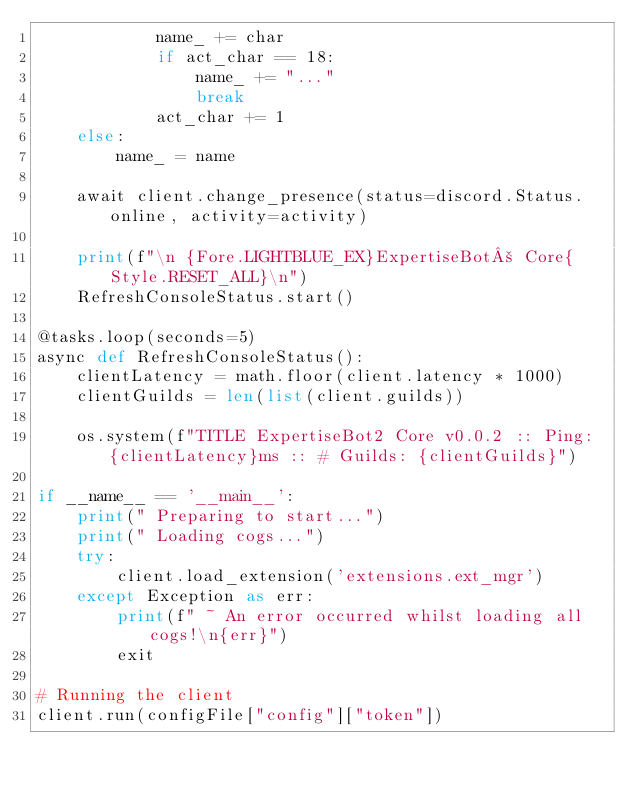Convert code to text. <code><loc_0><loc_0><loc_500><loc_500><_Python_>            name_ += char
            if act_char == 18:
                name_ += "..."
                break            
            act_char += 1
    else:
        name_ = name

    await client.change_presence(status=discord.Status.online, activity=activity)

    print(f"\n {Fore.LIGHTBLUE_EX}ExpertiseBot² Core{Style.RESET_ALL}\n")
    RefreshConsoleStatus.start()
    
@tasks.loop(seconds=5)
async def RefreshConsoleStatus():
    clientLatency = math.floor(client.latency * 1000)
    clientGuilds = len(list(client.guilds))
    
    os.system(f"TITLE ExpertiseBot2 Core v0.0.2 :: Ping: {clientLatency}ms :: # Guilds: {clientGuilds}")

if __name__ == '__main__':
    print(" Preparing to start...")
    print(" Loading cogs...")
    try:
        client.load_extension('extensions.ext_mgr')
    except Exception as err:
        print(f" ~ An error occurred whilst loading all cogs!\n{err}")
        exit

# Running the client
client.run(configFile["config"]["token"])
</code> 